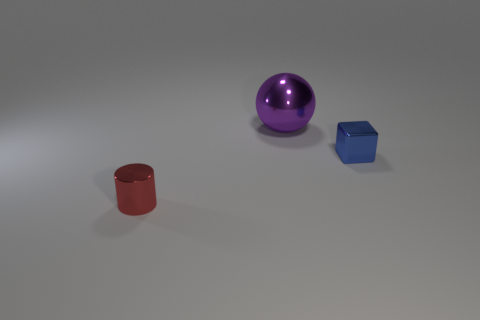Is there any other thing that is the same size as the purple shiny sphere?
Provide a short and direct response. No. There is a object that is both on the left side of the small shiny cube and behind the small metallic cylinder; what is its size?
Ensure brevity in your answer.  Large. What number of metallic things are either tiny red objects or big purple balls?
Offer a terse response. 2. Are there more metal blocks right of the cylinder than large brown matte cubes?
Give a very brief answer. Yes. There is a small thing that is right of the metallic cylinder; what is its material?
Your answer should be very brief. Metal. What number of blue things have the same material as the red cylinder?
Your answer should be compact. 1. There is a object that is both left of the small blue thing and on the right side of the red thing; what is its shape?
Provide a short and direct response. Sphere. How many things are shiny things that are in front of the blue metallic cube or objects on the left side of the small blue thing?
Your answer should be compact. 2. Are there an equal number of purple metallic spheres behind the large purple metal ball and tiny objects that are behind the red cylinder?
Give a very brief answer. No. What is the shape of the small object in front of the small metallic object to the right of the large purple object?
Give a very brief answer. Cylinder. 